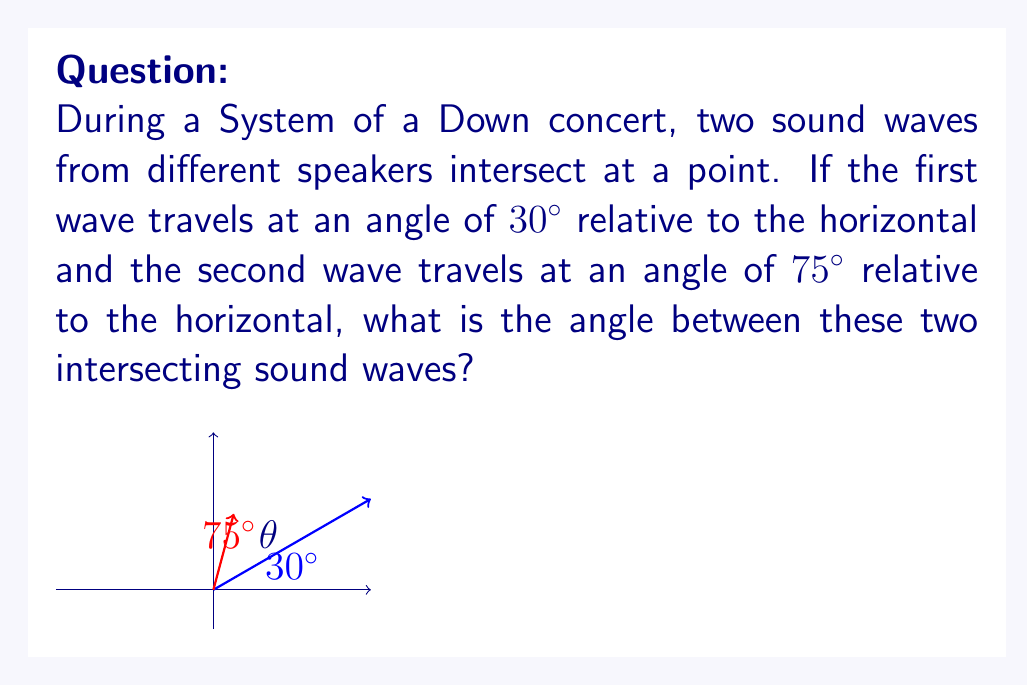Show me your answer to this math problem. Let's approach this step-by-step:

1) In this problem, we're dealing with the angle between two lines. The key concept here is that the angle between two lines is the absolute difference between their individual angles relative to a common reference line (in this case, the horizontal).

2) We're given:
   - First wave angle: $30^\circ$ from horizontal
   - Second wave angle: $75^\circ$ from horizontal

3) To find the angle between these waves, we subtract the smaller angle from the larger angle:

   $$\theta = |75^\circ - 30^\circ|$$

4) Calculating:
   $$\theta = 75^\circ - 30^\circ = 45^\circ$$

5) We take the absolute value to ensure a positive angle, but in this case, it's already positive.

Therefore, the angle between the two intersecting sound waves is $45^\circ$.
Answer: $45^\circ$ 